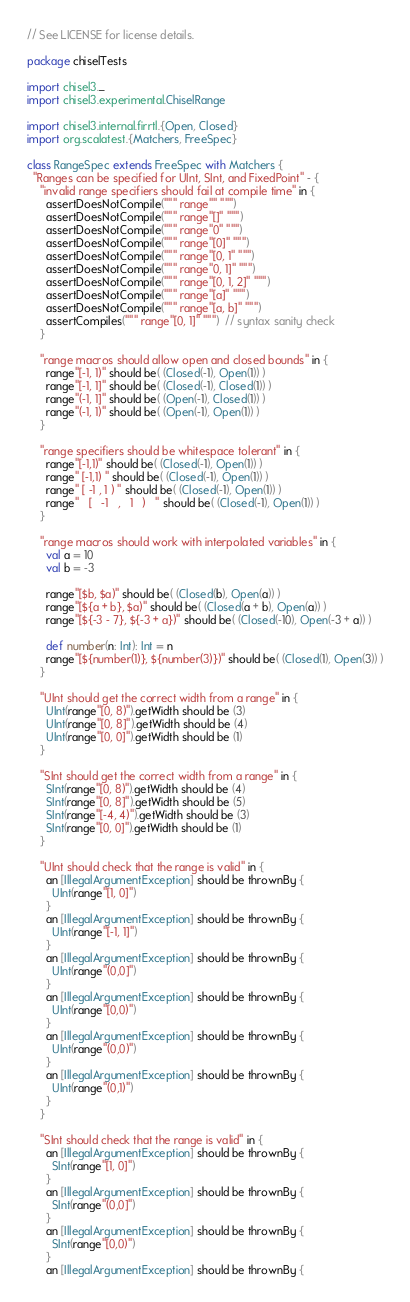<code> <loc_0><loc_0><loc_500><loc_500><_Scala_>// See LICENSE for license details.

package chiselTests

import chisel3._
import chisel3.experimental.ChiselRange

import chisel3.internal.firrtl.{Open, Closed}
import org.scalatest.{Matchers, FreeSpec}

class RangeSpec extends FreeSpec with Matchers {
  "Ranges can be specified for UInt, SInt, and FixedPoint" - {
    "invalid range specifiers should fail at compile time" in {
      assertDoesNotCompile(""" range"" """)
      assertDoesNotCompile(""" range"[]" """)
      assertDoesNotCompile(""" range"0" """)
      assertDoesNotCompile(""" range"[0]" """)
      assertDoesNotCompile(""" range"[0, 1" """)
      assertDoesNotCompile(""" range"0, 1]" """)
      assertDoesNotCompile(""" range"[0, 1, 2]" """)
      assertDoesNotCompile(""" range"[a]" """)
      assertDoesNotCompile(""" range"[a, b]" """)
      assertCompiles(""" range"[0, 1]" """)  // syntax sanity check
    }

    "range macros should allow open and closed bounds" in {
      range"[-1, 1)" should be( (Closed(-1), Open(1)) )
      range"[-1, 1]" should be( (Closed(-1), Closed(1)) )
      range"(-1, 1]" should be( (Open(-1), Closed(1)) )
      range"(-1, 1)" should be( (Open(-1), Open(1)) )
    }

    "range specifiers should be whitespace tolerant" in {
      range"[-1,1)" should be( (Closed(-1), Open(1)) )
      range" [-1,1) " should be( (Closed(-1), Open(1)) )
      range" [ -1 , 1 ) " should be( (Closed(-1), Open(1)) )
      range"   [   -1   ,   1   )   " should be( (Closed(-1), Open(1)) )
    }

    "range macros should work with interpolated variables" in {
      val a = 10
      val b = -3

      range"[$b, $a)" should be( (Closed(b), Open(a)) )
      range"[${a + b}, $a)" should be( (Closed(a + b), Open(a)) )
      range"[${-3 - 7}, ${-3 + a})" should be( (Closed(-10), Open(-3 + a)) )

      def number(n: Int): Int = n
      range"[${number(1)}, ${number(3)})" should be( (Closed(1), Open(3)) )
    }

    "UInt should get the correct width from a range" in {
      UInt(range"[0, 8)").getWidth should be (3)
      UInt(range"[0, 8]").getWidth should be (4)
      UInt(range"[0, 0]").getWidth should be (1)
    }

    "SInt should get the correct width from a range" in {
      SInt(range"[0, 8)").getWidth should be (4)
      SInt(range"[0, 8]").getWidth should be (5)
      SInt(range"[-4, 4)").getWidth should be (3)
      SInt(range"[0, 0]").getWidth should be (1)
    }

    "UInt should check that the range is valid" in {
      an [IllegalArgumentException] should be thrownBy {
        UInt(range"[1, 0]")
      }
      an [IllegalArgumentException] should be thrownBy {
        UInt(range"[-1, 1]")
      }
      an [IllegalArgumentException] should be thrownBy {
        UInt(range"(0,0]")
      }
      an [IllegalArgumentException] should be thrownBy {
        UInt(range"[0,0)")
      }
      an [IllegalArgumentException] should be thrownBy {
        UInt(range"(0,0)")
      }
      an [IllegalArgumentException] should be thrownBy {
        UInt(range"(0,1)")
      }
    }

    "SInt should check that the range is valid" in {
      an [IllegalArgumentException] should be thrownBy {
        SInt(range"[1, 0]")
      }
      an [IllegalArgumentException] should be thrownBy {
        SInt(range"(0,0]")
      }
      an [IllegalArgumentException] should be thrownBy {
        SInt(range"[0,0)")
      }
      an [IllegalArgumentException] should be thrownBy {</code> 